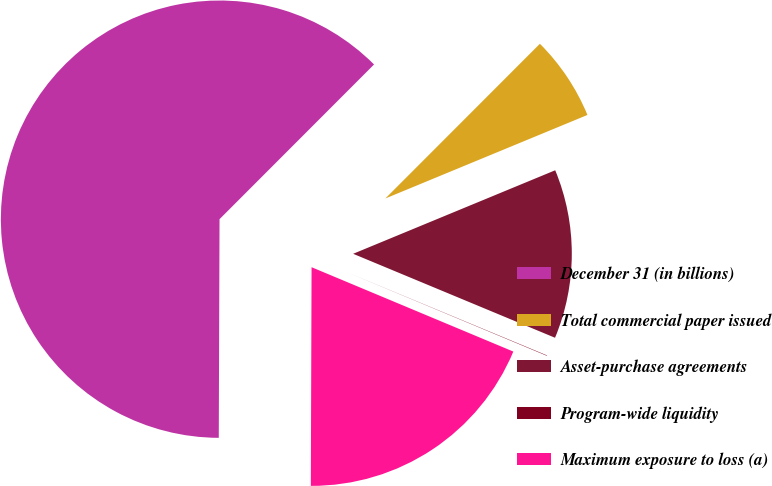Convert chart to OTSL. <chart><loc_0><loc_0><loc_500><loc_500><pie_chart><fcel>December 31 (in billions)<fcel>Total commercial paper issued<fcel>Asset-purchase agreements<fcel>Program-wide liquidity<fcel>Maximum exposure to loss (a)<nl><fcel>62.43%<fcel>6.27%<fcel>12.51%<fcel>0.03%<fcel>18.75%<nl></chart> 